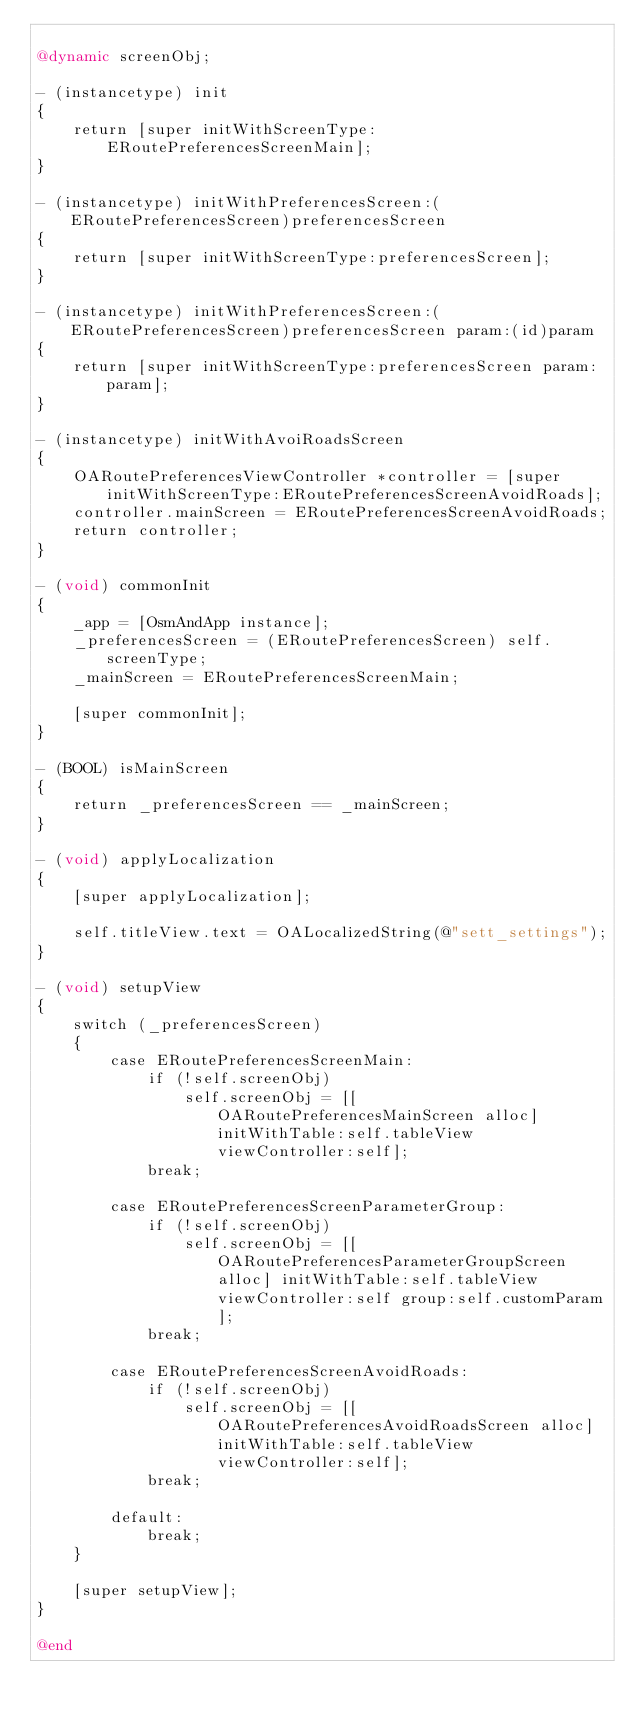Convert code to text. <code><loc_0><loc_0><loc_500><loc_500><_ObjectiveC_>
@dynamic screenObj;

- (instancetype) init
{
    return [super initWithScreenType:ERoutePreferencesScreenMain];
}

- (instancetype) initWithPreferencesScreen:(ERoutePreferencesScreen)preferencesScreen
{
    return [super initWithScreenType:preferencesScreen];
}

- (instancetype) initWithPreferencesScreen:(ERoutePreferencesScreen)preferencesScreen param:(id)param
{
    return [super initWithScreenType:preferencesScreen param:param];
}

- (instancetype) initWithAvoiRoadsScreen
{
    OARoutePreferencesViewController *controller = [super initWithScreenType:ERoutePreferencesScreenAvoidRoads];
    controller.mainScreen = ERoutePreferencesScreenAvoidRoads;
    return controller;
}

- (void) commonInit
{
    _app = [OsmAndApp instance];
    _preferencesScreen = (ERoutePreferencesScreen) self.screenType;
    _mainScreen = ERoutePreferencesScreenMain;
    
    [super commonInit];
}

- (BOOL) isMainScreen
{
    return _preferencesScreen == _mainScreen;
}

- (void) applyLocalization
{
    [super applyLocalization];
    
    self.titleView.text = OALocalizedString(@"sett_settings");
}

- (void) setupView
{
    switch (_preferencesScreen)
    {
        case ERoutePreferencesScreenMain:
            if (!self.screenObj)
                self.screenObj = [[OARoutePreferencesMainScreen alloc] initWithTable:self.tableView viewController:self];
            break;

        case ERoutePreferencesScreenParameterGroup:
            if (!self.screenObj)
                self.screenObj = [[OARoutePreferencesParameterGroupScreen alloc] initWithTable:self.tableView viewController:self group:self.customParam];
            break;

        case ERoutePreferencesScreenAvoidRoads:
            if (!self.screenObj)
                self.screenObj = [[OARoutePreferencesAvoidRoadsScreen alloc] initWithTable:self.tableView viewController:self];
            break;

        default:
            break;
    }
    
    [super setupView];
}

@end
</code> 